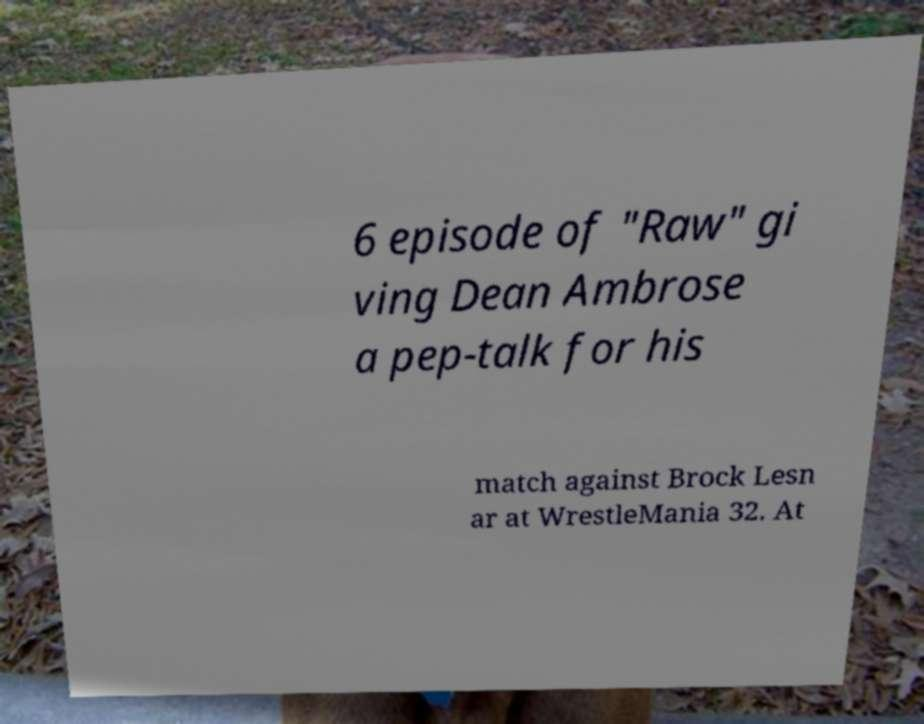There's text embedded in this image that I need extracted. Can you transcribe it verbatim? 6 episode of "Raw" gi ving Dean Ambrose a pep-talk for his match against Brock Lesn ar at WrestleMania 32. At 